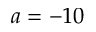<formula> <loc_0><loc_0><loc_500><loc_500>a = - 1 0</formula> 